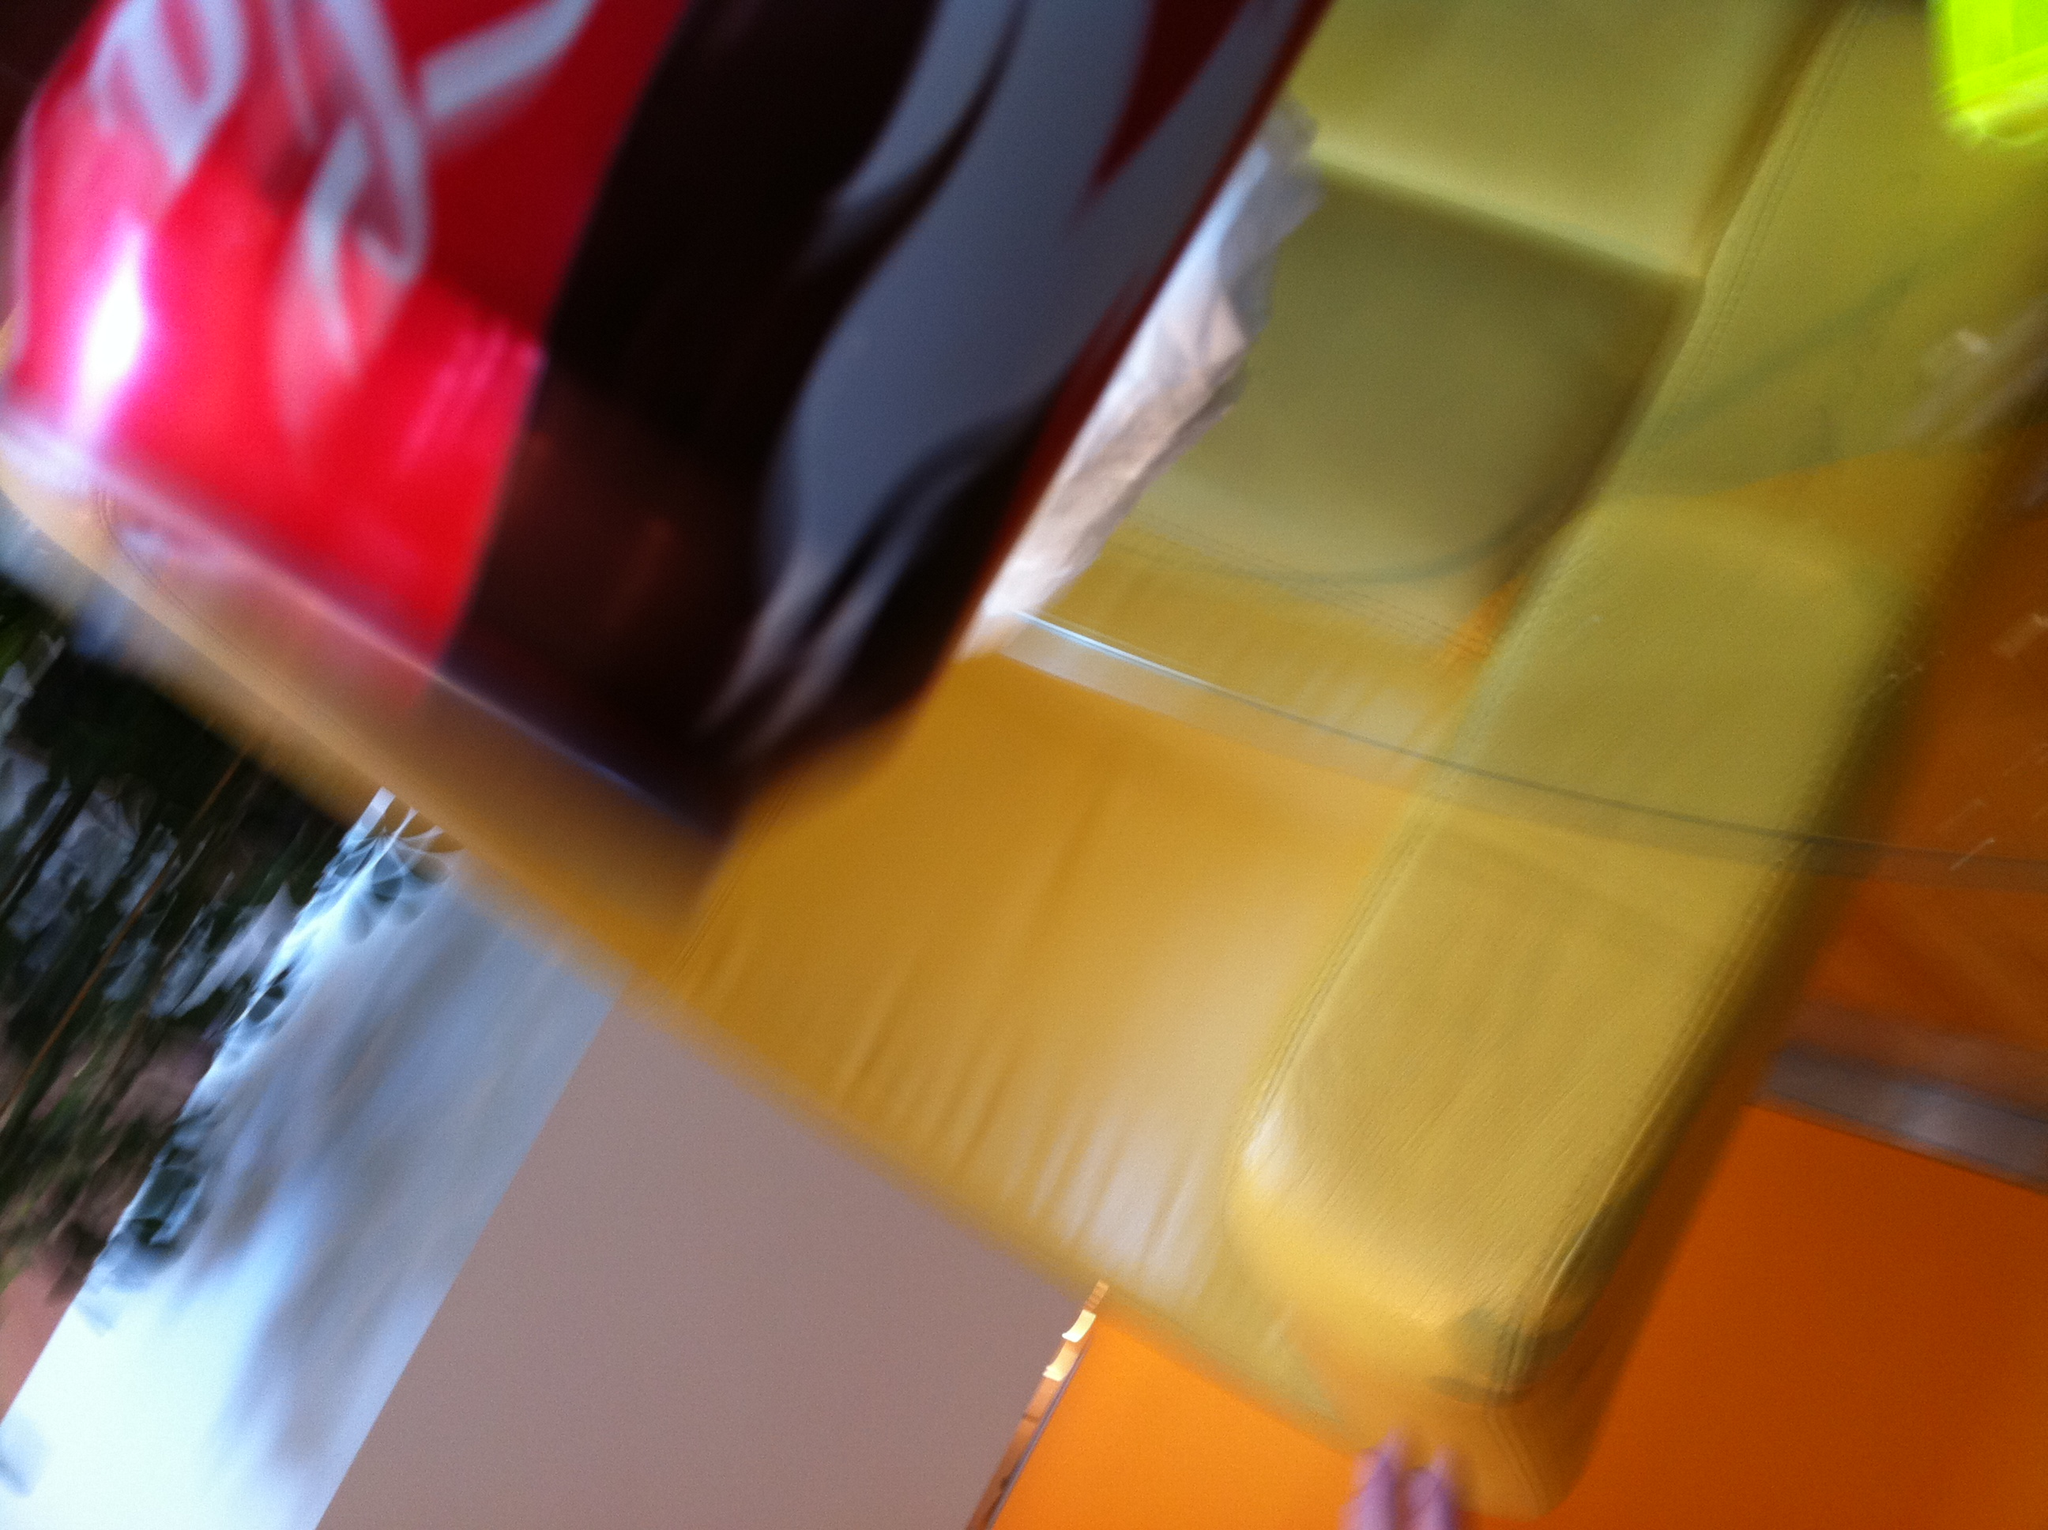what drink is this? from Vizwiz The drink in the image is a can of Coca-Cola, recognizable by the distinctive red logo and script visible on the can. 